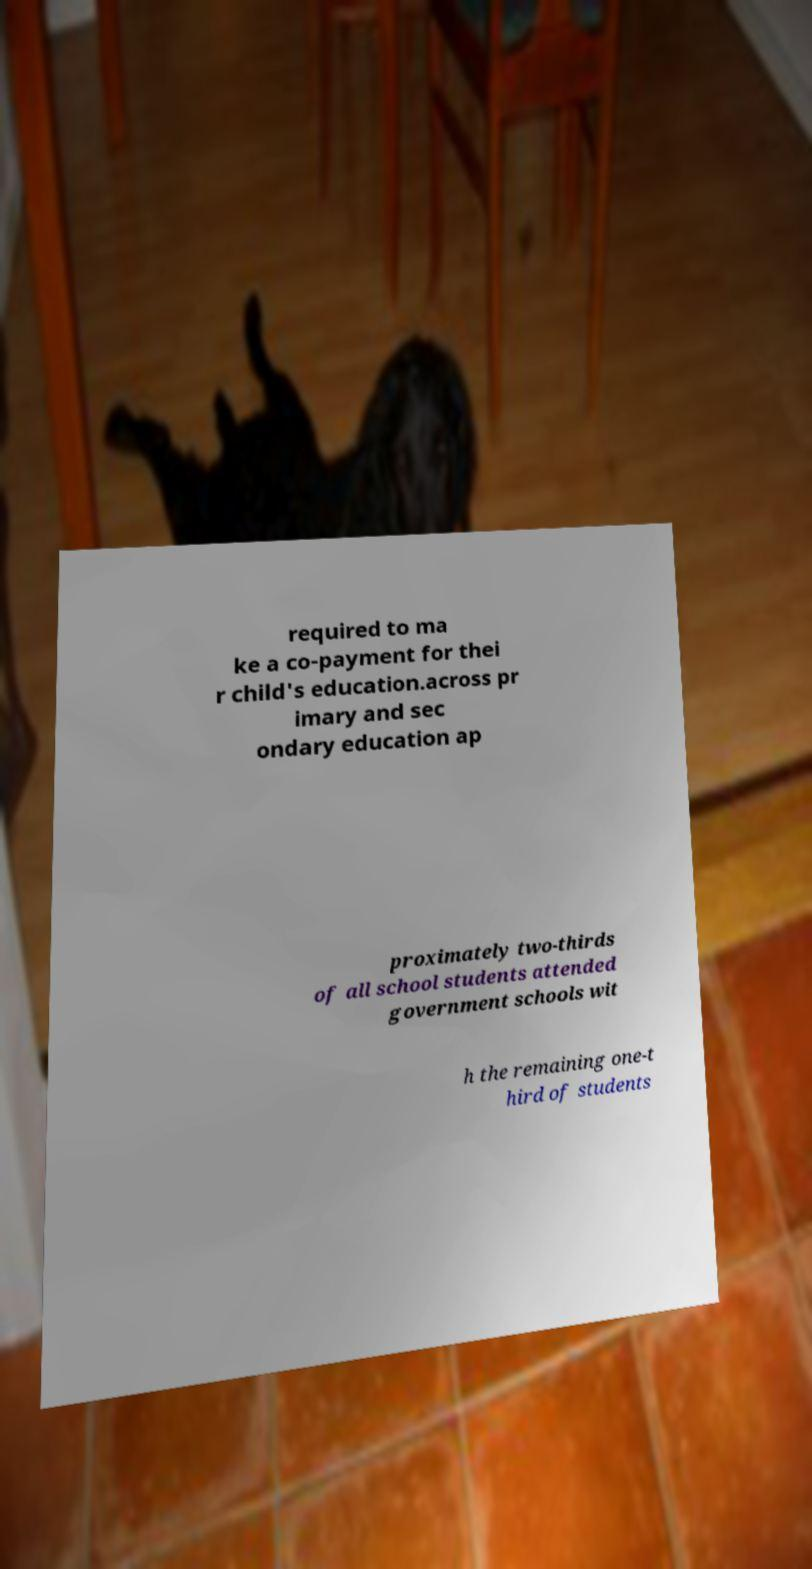There's text embedded in this image that I need extracted. Can you transcribe it verbatim? required to ma ke a co-payment for thei r child's education.across pr imary and sec ondary education ap proximately two-thirds of all school students attended government schools wit h the remaining one-t hird of students 